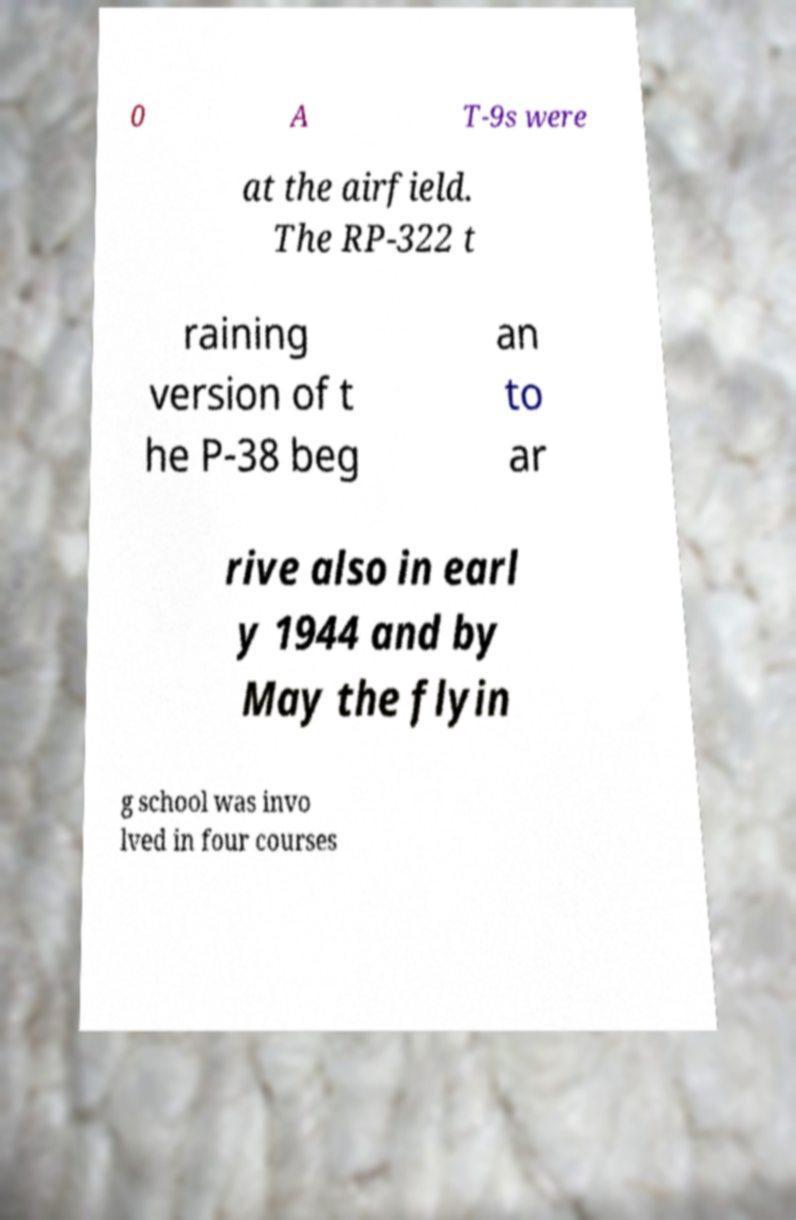Could you extract and type out the text from this image? 0 A T-9s were at the airfield. The RP-322 t raining version of t he P-38 beg an to ar rive also in earl y 1944 and by May the flyin g school was invo lved in four courses 